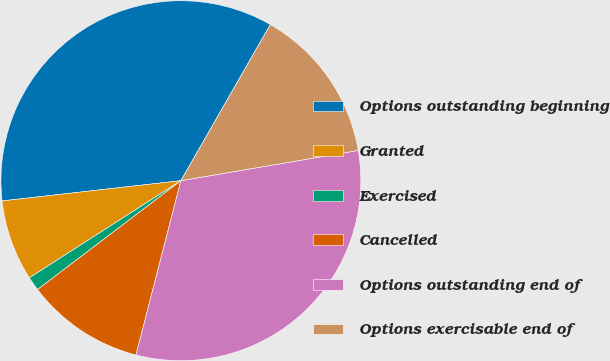Convert chart. <chart><loc_0><loc_0><loc_500><loc_500><pie_chart><fcel>Options outstanding beginning<fcel>Granted<fcel>Exercised<fcel>Cancelled<fcel>Options outstanding end of<fcel>Options exercisable end of<nl><fcel>35.07%<fcel>7.28%<fcel>1.26%<fcel>10.65%<fcel>31.7%<fcel>14.03%<nl></chart> 